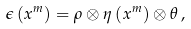Convert formula to latex. <formula><loc_0><loc_0><loc_500><loc_500>\epsilon \left ( x ^ { m } \right ) = \rho \otimes \eta \left ( x ^ { m } \right ) \otimes \theta \, ,</formula> 